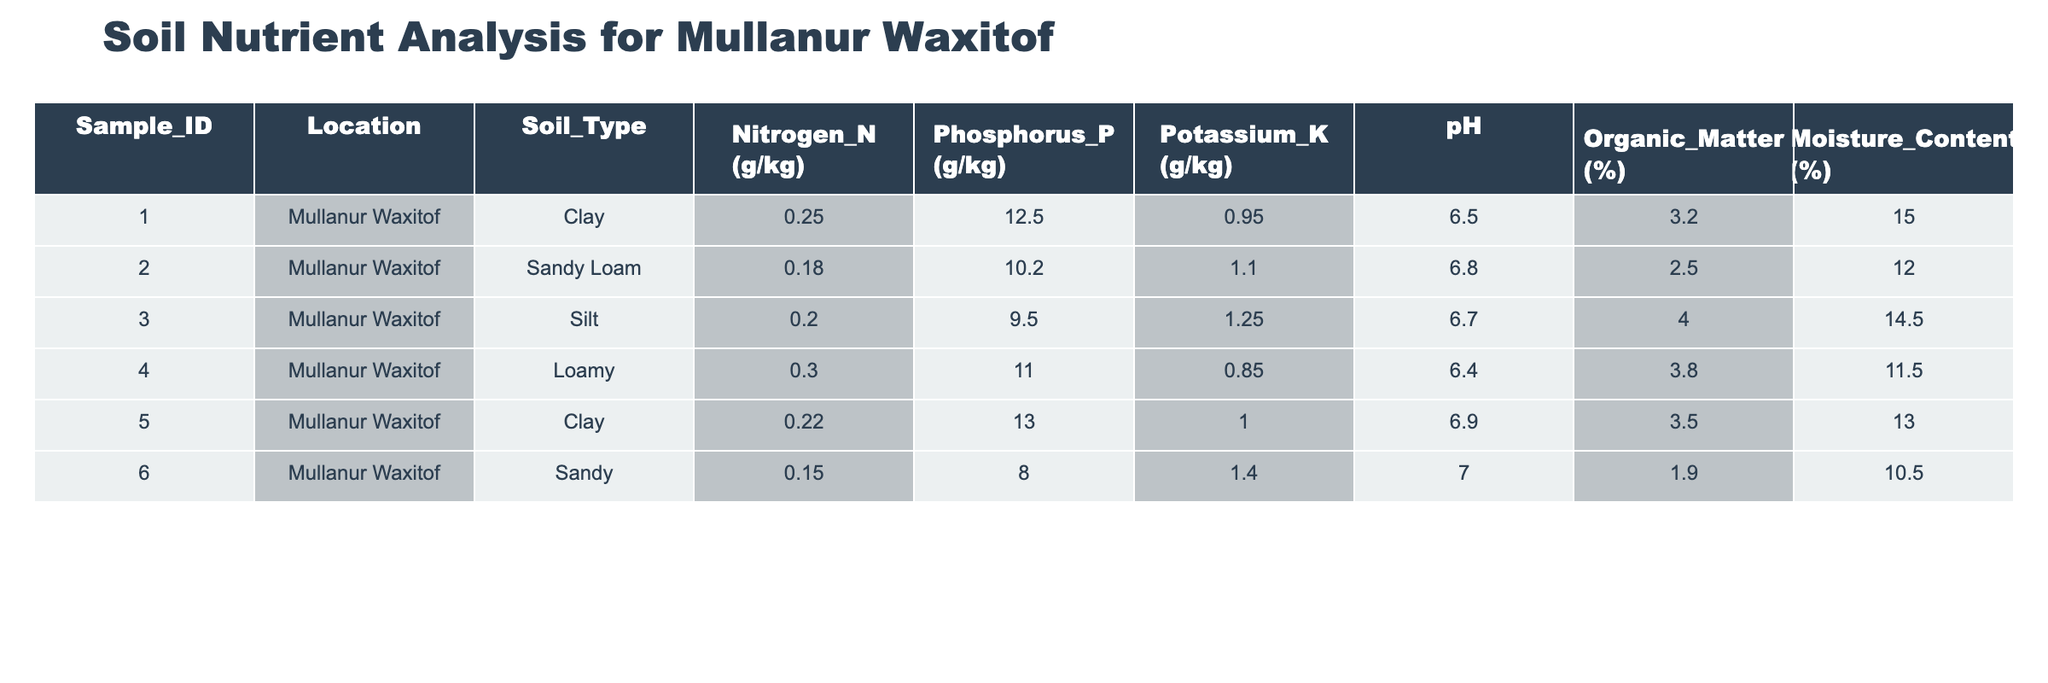What is the nitrogen content in the sandy soil sample? The sandy soil sample has an identification number of 006. Upon checking the table, the nitrogen content listed for this sample is 0.15 g/kg.
Answer: 0.15 g/kg Which soil type has the highest phosphorus content? Reviewing the phosphorus values for each soil type, clay has two samples (001 and 005) with values of 12.5 g/kg and 13.0 g/kg respectively, compared to others. The highest value is 13.0 g/kg from sample 005 (Clay).
Answer: Clay (13.0 g/kg) What is the average potassium content across all samples? Summing the potassium values from all samples gives: 0.95 + 1.10 + 1.25 + 0.85 + 1.00 + 1.40 = 6.55 g/kg. There are six samples, so the average potassium content is 6.55 / 6 = 1.092 g/kg.
Answer: 1.092 g/kg Is the pH level of the loamy soil sample considered acidic? The pH of the loamy soil sample identified as 004 is 6.4. A pH level below 7 is categorized as acidic. Since 6.4 is less than 7, we conclude that it is indeed acidic.
Answer: Yes What is the difference in organic matter percentage between the samples with the highest and lowest moisture content? The sample with the highest moisture content is sample 001 (Clay) at 15.0%, while the sample with the lowest moisture content is sample 006 (Sandy) at 10.5%. The difference is 15.0 - 10.5 = 4.5%.
Answer: 4.5% 